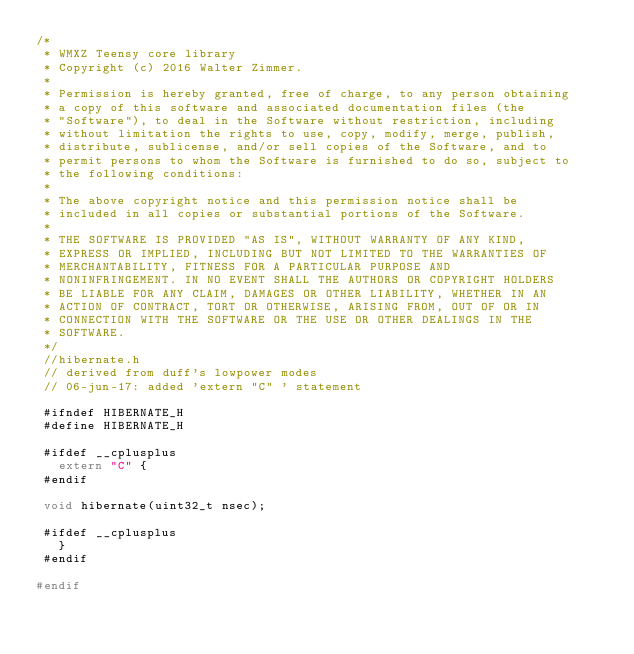<code> <loc_0><loc_0><loc_500><loc_500><_C_>/*
 * WMXZ Teensy core library
 * Copyright (c) 2016 Walter Zimmer.
 *
 * Permission is hereby granted, free of charge, to any person obtaining
 * a copy of this software and associated documentation files (the
 * "Software"), to deal in the Software without restriction, including
 * without limitation the rights to use, copy, modify, merge, publish,
 * distribute, sublicense, and/or sell copies of the Software, and to
 * permit persons to whom the Software is furnished to do so, subject to
 * the following conditions:
 *
 * The above copyright notice and this permission notice shall be
 * included in all copies or substantial portions of the Software.
 *
 * THE SOFTWARE IS PROVIDED "AS IS", WITHOUT WARRANTY OF ANY KIND,
 * EXPRESS OR IMPLIED, INCLUDING BUT NOT LIMITED TO THE WARRANTIES OF
 * MERCHANTABILITY, FITNESS FOR A PARTICULAR PURPOSE AND
 * NONINFRINGEMENT. IN NO EVENT SHALL THE AUTHORS OR COPYRIGHT HOLDERS
 * BE LIABLE FOR ANY CLAIM, DAMAGES OR OTHER LIABILITY, WHETHER IN AN
 * ACTION OF CONTRACT, TORT OR OTHERWISE, ARISING FROM, OUT OF OR IN
 * CONNECTION WITH THE SOFTWARE OR THE USE OR OTHER DEALINGS IN THE
 * SOFTWARE.
 */
 //hibernate.h
 // derived from duff's lowpower modes
 // 06-jun-17: added 'extern "C" ' statement

 #ifndef HIBERNATE_H
 #define HIBERNATE_H
 
 #ifdef __cplusplus
   extern "C" {
 #endif

 void hibernate(uint32_t nsec);
	
 #ifdef __cplusplus
   }
 #endif

#endif
</code> 